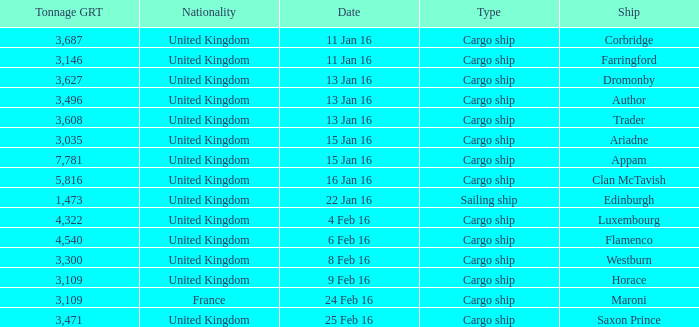What is the nationality of the ship appam? United Kingdom. 